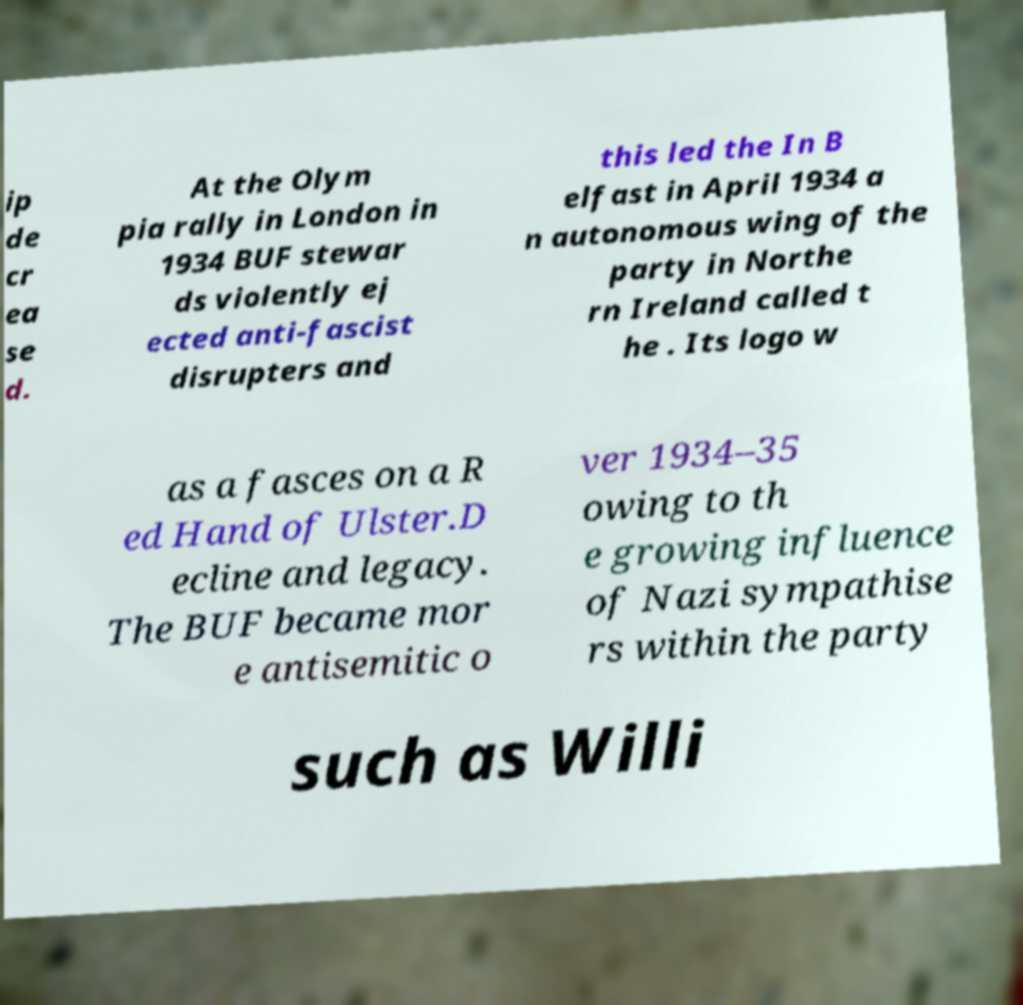I need the written content from this picture converted into text. Can you do that? ip de cr ea se d. At the Olym pia rally in London in 1934 BUF stewar ds violently ej ected anti-fascist disrupters and this led the In B elfast in April 1934 a n autonomous wing of the party in Northe rn Ireland called t he . Its logo w as a fasces on a R ed Hand of Ulster.D ecline and legacy. The BUF became mor e antisemitic o ver 1934–35 owing to th e growing influence of Nazi sympathise rs within the party such as Willi 